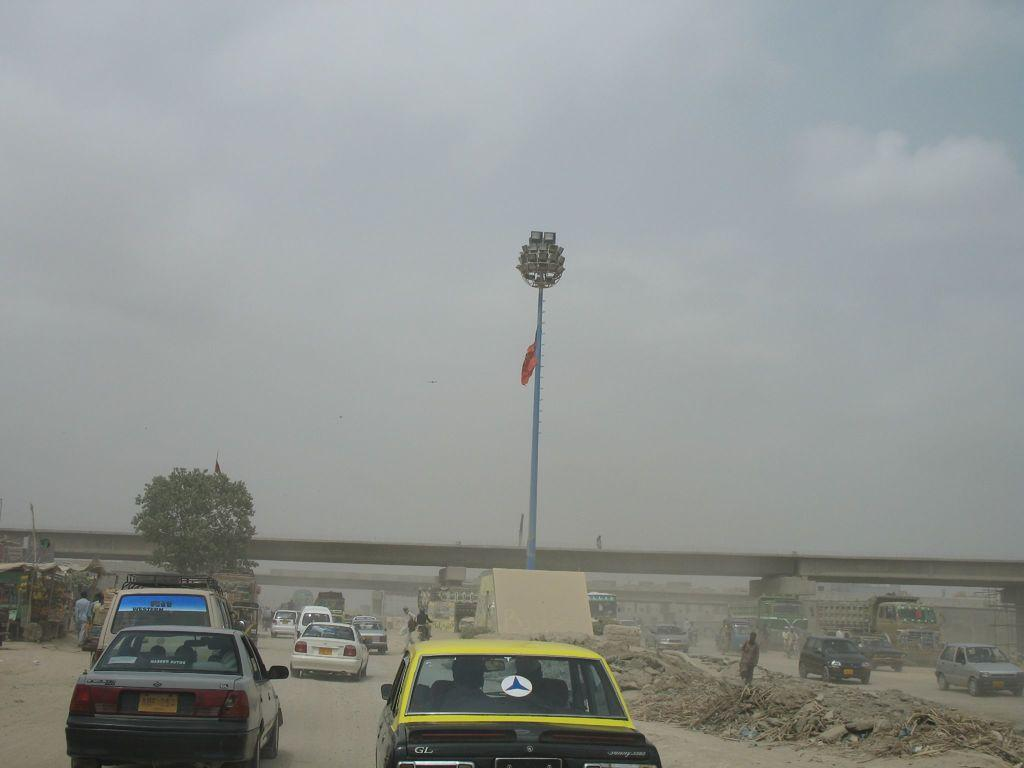What types of objects are present in the image? There are vehicles and a group of people in the image. What can be seen in the background of the image? In the background, there are poles, lights, a tree, and a bridge. How many vehicles are visible in the image? The number of vehicles is not specified, but there are at least two vehicles present. What does the fireman's dad do at night in the image? There is no fireman, dad, or nighttime setting depicted in the image. 